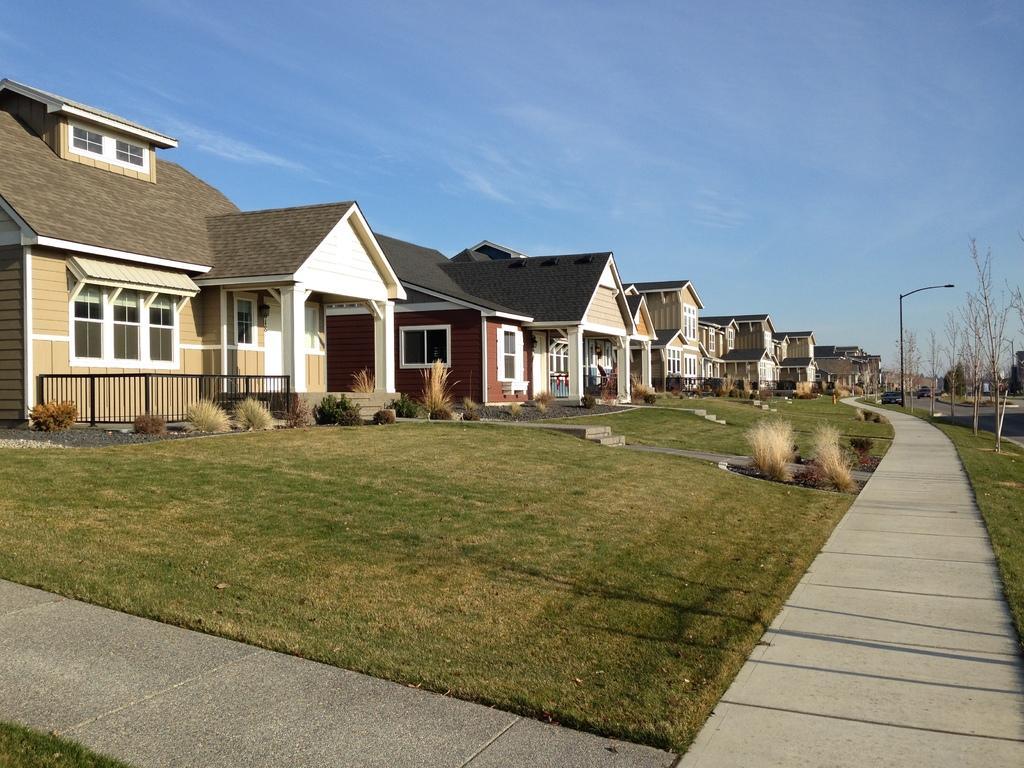Could you give a brief overview of what you see in this image? In the foreground of the image, we can see grassy land and the pathway. In the background, we can see buildings, fence, plants, stairs, trees and a street light. At the top of the image, we can see the sky. We can see the road on the right side of the image. 